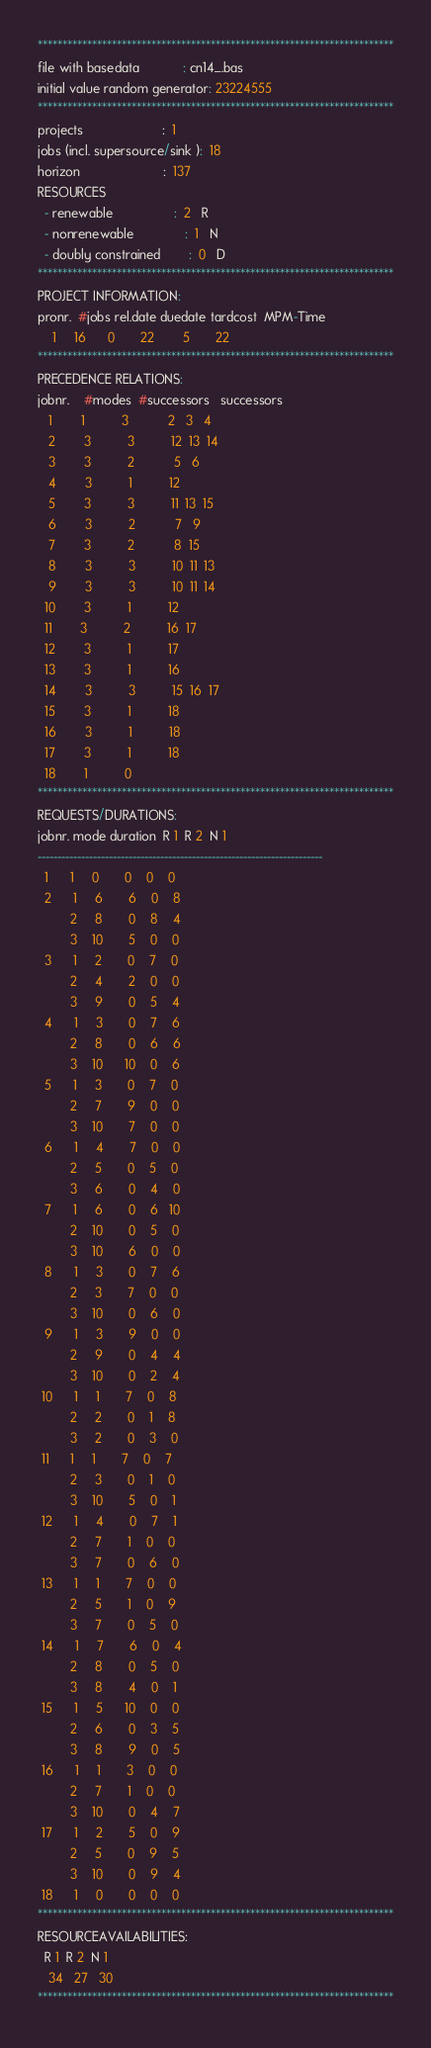Convert code to text. <code><loc_0><loc_0><loc_500><loc_500><_ObjectiveC_>************************************************************************
file with basedata            : cn14_.bas
initial value random generator: 23224555
************************************************************************
projects                      :  1
jobs (incl. supersource/sink ):  18
horizon                       :  137
RESOURCES
  - renewable                 :  2   R
  - nonrenewable              :  1   N
  - doubly constrained        :  0   D
************************************************************************
PROJECT INFORMATION:
pronr.  #jobs rel.date duedate tardcost  MPM-Time
    1     16      0       22        5       22
************************************************************************
PRECEDENCE RELATIONS:
jobnr.    #modes  #successors   successors
   1        1          3           2   3   4
   2        3          3          12  13  14
   3        3          2           5   6
   4        3          1          12
   5        3          3          11  13  15
   6        3          2           7   9
   7        3          2           8  15
   8        3          3          10  11  13
   9        3          3          10  11  14
  10        3          1          12
  11        3          2          16  17
  12        3          1          17
  13        3          1          16
  14        3          3          15  16  17
  15        3          1          18
  16        3          1          18
  17        3          1          18
  18        1          0        
************************************************************************
REQUESTS/DURATIONS:
jobnr. mode duration  R 1  R 2  N 1
------------------------------------------------------------------------
  1      1     0       0    0    0
  2      1     6       6    0    8
         2     8       0    8    4
         3    10       5    0    0
  3      1     2       0    7    0
         2     4       2    0    0
         3     9       0    5    4
  4      1     3       0    7    6
         2     8       0    6    6
         3    10      10    0    6
  5      1     3       0    7    0
         2     7       9    0    0
         3    10       7    0    0
  6      1     4       7    0    0
         2     5       0    5    0
         3     6       0    4    0
  7      1     6       0    6   10
         2    10       0    5    0
         3    10       6    0    0
  8      1     3       0    7    6
         2     3       7    0    0
         3    10       0    6    0
  9      1     3       9    0    0
         2     9       0    4    4
         3    10       0    2    4
 10      1     1       7    0    8
         2     2       0    1    8
         3     2       0    3    0
 11      1     1       7    0    7
         2     3       0    1    0
         3    10       5    0    1
 12      1     4       0    7    1
         2     7       1    0    0
         3     7       0    6    0
 13      1     1       7    0    0
         2     5       1    0    9
         3     7       0    5    0
 14      1     7       6    0    4
         2     8       0    5    0
         3     8       4    0    1
 15      1     5      10    0    0
         2     6       0    3    5
         3     8       9    0    5
 16      1     1       3    0    0
         2     7       1    0    0
         3    10       0    4    7
 17      1     2       5    0    9
         2     5       0    9    5
         3    10       0    9    4
 18      1     0       0    0    0
************************************************************************
RESOURCEAVAILABILITIES:
  R 1  R 2  N 1
   34   27   30
************************************************************************
</code> 